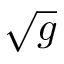<formula> <loc_0><loc_0><loc_500><loc_500>\sqrt { g }</formula> 